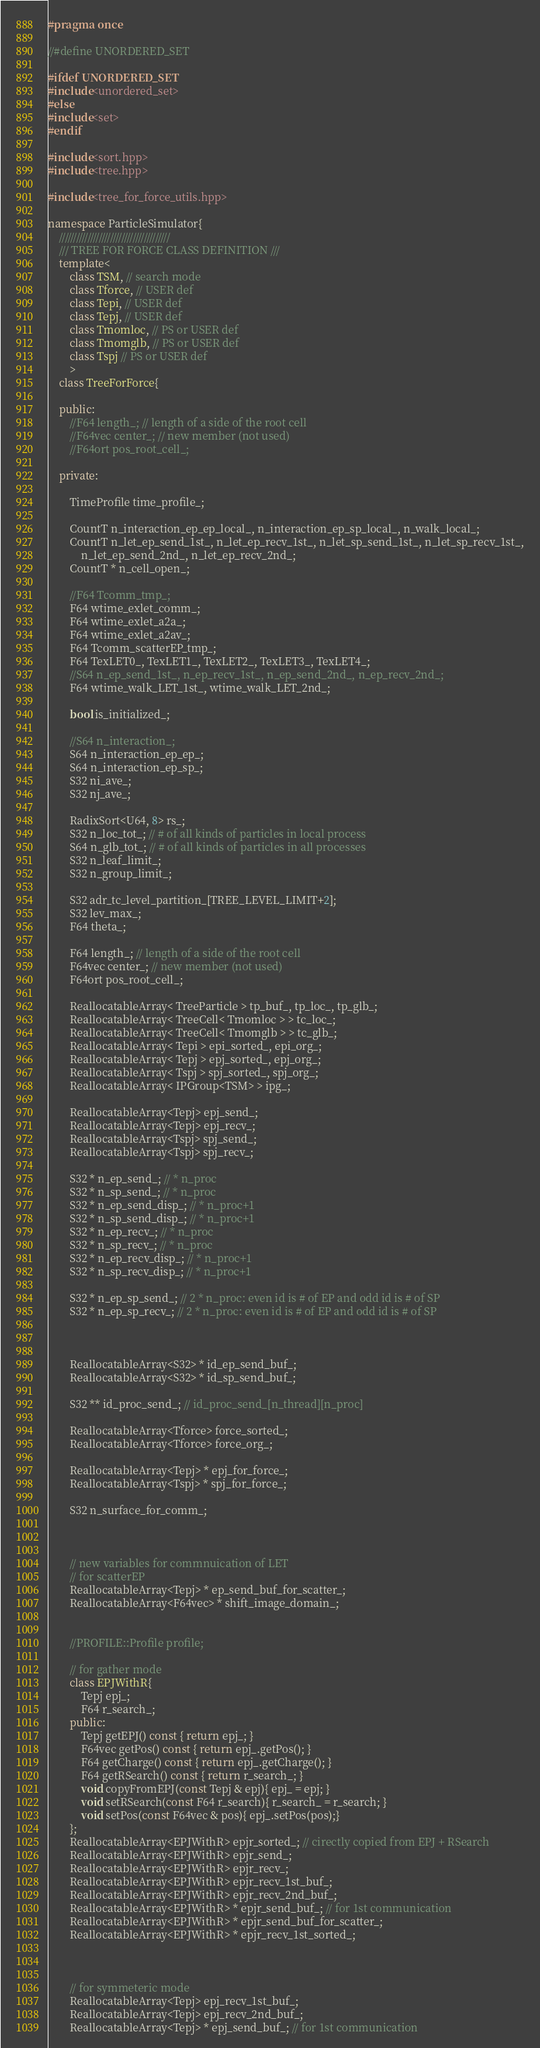<code> <loc_0><loc_0><loc_500><loc_500><_C++_>#pragma once

//#define UNORDERED_SET

#ifdef UNORDERED_SET 
#include<unordered_set>
#else
#include<set>
#endif

#include<sort.hpp>
#include<tree.hpp>

#include<tree_for_force_utils.hpp>

namespace ParticleSimulator{
    ///////////////////////////////////////
    /// TREE FOR FORCE CLASS DEFINITION ///
    template<
        class TSM, // search mode
        class Tforce, // USER def
        class Tepi, // USER def
        class Tepj, // USER def
        class Tmomloc, // PS or USER def
        class Tmomglb, // PS or USER def
        class Tspj // PS or USER def
        >
    class TreeForForce{

    public:
        //F64 length_; // length of a side of the root cell
        //F64vec center_; // new member (not used)
        //F64ort pos_root_cell_;

    private:

        TimeProfile time_profile_;

        CountT n_interaction_ep_ep_local_, n_interaction_ep_sp_local_, n_walk_local_;
        CountT n_let_ep_send_1st_, n_let_ep_recv_1st_, n_let_sp_send_1st_, n_let_sp_recv_1st_,
            n_let_ep_send_2nd_, n_let_ep_recv_2nd_;
        CountT * n_cell_open_;

        //F64 Tcomm_tmp_;
        F64 wtime_exlet_comm_;
        F64 wtime_exlet_a2a_;
        F64 wtime_exlet_a2av_;
        F64 Tcomm_scatterEP_tmp_;
        F64 TexLET0_, TexLET1_, TexLET2_, TexLET3_, TexLET4_;
        //S64 n_ep_send_1st_, n_ep_recv_1st_, n_ep_send_2nd_, n_ep_recv_2nd_;
        F64 wtime_walk_LET_1st_, wtime_walk_LET_2nd_;

        bool is_initialized_;

        //S64 n_interaction_;
        S64 n_interaction_ep_ep_;
        S64 n_interaction_ep_sp_;
        S32 ni_ave_;
        S32 nj_ave_;

        RadixSort<U64, 8> rs_;
        S32 n_loc_tot_; // # of all kinds of particles in local process
        S64 n_glb_tot_; // # of all kinds of particles in all processes
        S32 n_leaf_limit_;
        S32 n_group_limit_;

        S32 adr_tc_level_partition_[TREE_LEVEL_LIMIT+2];
        S32 lev_max_;
        F64 theta_;

        F64 length_; // length of a side of the root cell
        F64vec center_; // new member (not used)
        F64ort pos_root_cell_;

        ReallocatableArray< TreeParticle > tp_buf_, tp_loc_, tp_glb_;
        ReallocatableArray< TreeCell< Tmomloc > > tc_loc_;
        ReallocatableArray< TreeCell< Tmomglb > > tc_glb_;
        ReallocatableArray< Tepi > epi_sorted_, epi_org_;
        ReallocatableArray< Tepj > epj_sorted_, epj_org_;
        ReallocatableArray< Tspj > spj_sorted_, spj_org_;
        ReallocatableArray< IPGroup<TSM> > ipg_;
	
        ReallocatableArray<Tepj> epj_send_;
        ReallocatableArray<Tepj> epj_recv_;
        ReallocatableArray<Tspj> spj_send_;
        ReallocatableArray<Tspj> spj_recv_;

        S32 * n_ep_send_; // * n_proc
        S32 * n_sp_send_; // * n_proc
        S32 * n_ep_send_disp_; // * n_proc+1
        S32 * n_sp_send_disp_; // * n_proc+1
        S32 * n_ep_recv_; // * n_proc
        S32 * n_sp_recv_; // * n_proc
        S32 * n_ep_recv_disp_; // * n_proc+1
        S32 * n_sp_recv_disp_; // * n_proc+1

        S32 * n_ep_sp_send_; // 2 * n_proc: even id is # of EP and odd id is # of SP
        S32 * n_ep_sp_recv_; // 2 * n_proc: even id is # of EP and odd id is # of SP



        ReallocatableArray<S32> * id_ep_send_buf_;
        ReallocatableArray<S32> * id_sp_send_buf_;

        S32 ** id_proc_send_; // id_proc_send_[n_thread][n_proc]

        ReallocatableArray<Tforce> force_sorted_;
        ReallocatableArray<Tforce> force_org_;

        ReallocatableArray<Tepj> * epj_for_force_;
        ReallocatableArray<Tspj> * spj_for_force_;

        S32 n_surface_for_comm_;



        // new variables for commnuication of LET
        // for scatterEP
        ReallocatableArray<Tepj> * ep_send_buf_for_scatter_;
        ReallocatableArray<F64vec> * shift_image_domain_;


        //PROFILE::Profile profile;

        // for gather mode
        class EPJWithR{
            Tepj epj_;
            F64 r_search_;
        public:
            Tepj getEPJ() const { return epj_; }
            F64vec getPos() const { return epj_.getPos(); }
            F64 getCharge() const { return epj_.getCharge(); }
            F64 getRSearch() const { return r_search_; }
            void copyFromEPJ(const Tepj & epj){ epj_ = epj; }
            void setRSearch(const F64 r_search){ r_search_ = r_search; }
            void setPos(const F64vec & pos){ epj_.setPos(pos);}
        };
        ReallocatableArray<EPJWithR> epjr_sorted_; // cirectly copied from EPJ + RSearch
        ReallocatableArray<EPJWithR> epjr_send_;
        ReallocatableArray<EPJWithR> epjr_recv_;
        ReallocatableArray<EPJWithR> epjr_recv_1st_buf_;
        ReallocatableArray<EPJWithR> epjr_recv_2nd_buf_;
        ReallocatableArray<EPJWithR> * epjr_send_buf_; // for 1st communication
        ReallocatableArray<EPJWithR> * epjr_send_buf_for_scatter_;
        ReallocatableArray<EPJWithR> * epjr_recv_1st_sorted_;



        // for symmeteric mode
        ReallocatableArray<Tepj> epj_recv_1st_buf_;
        ReallocatableArray<Tepj> epj_recv_2nd_buf_;
        ReallocatableArray<Tepj> * epj_send_buf_; // for 1st communication</code> 